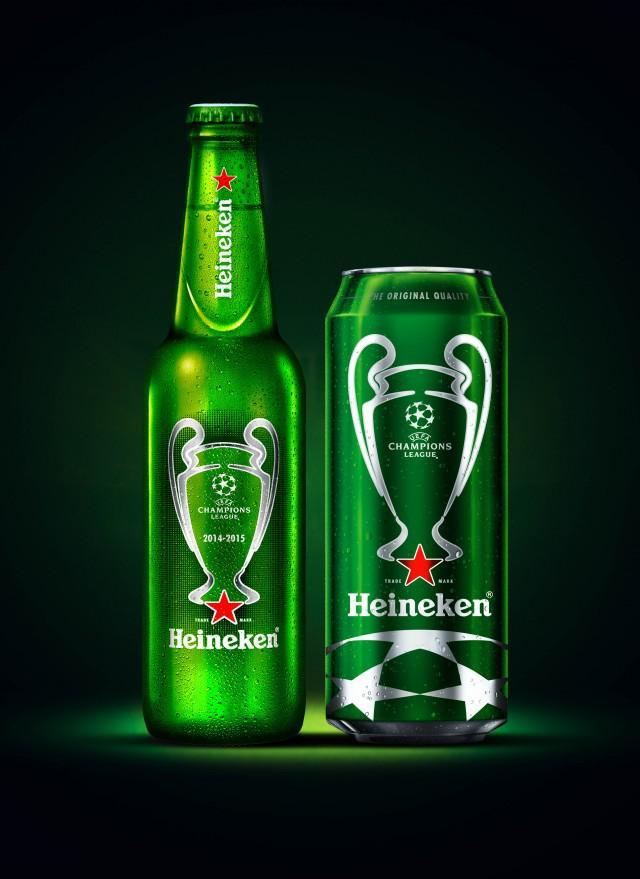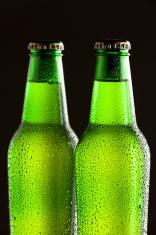The first image is the image on the left, the second image is the image on the right. Examine the images to the left and right. Is the description "A single green beer bottle is shown in one image." accurate? Answer yes or no. Yes. The first image is the image on the left, the second image is the image on the right. Examine the images to the left and right. Is the description "An image contains exactly two bottles displayed vertically." accurate? Answer yes or no. Yes. 